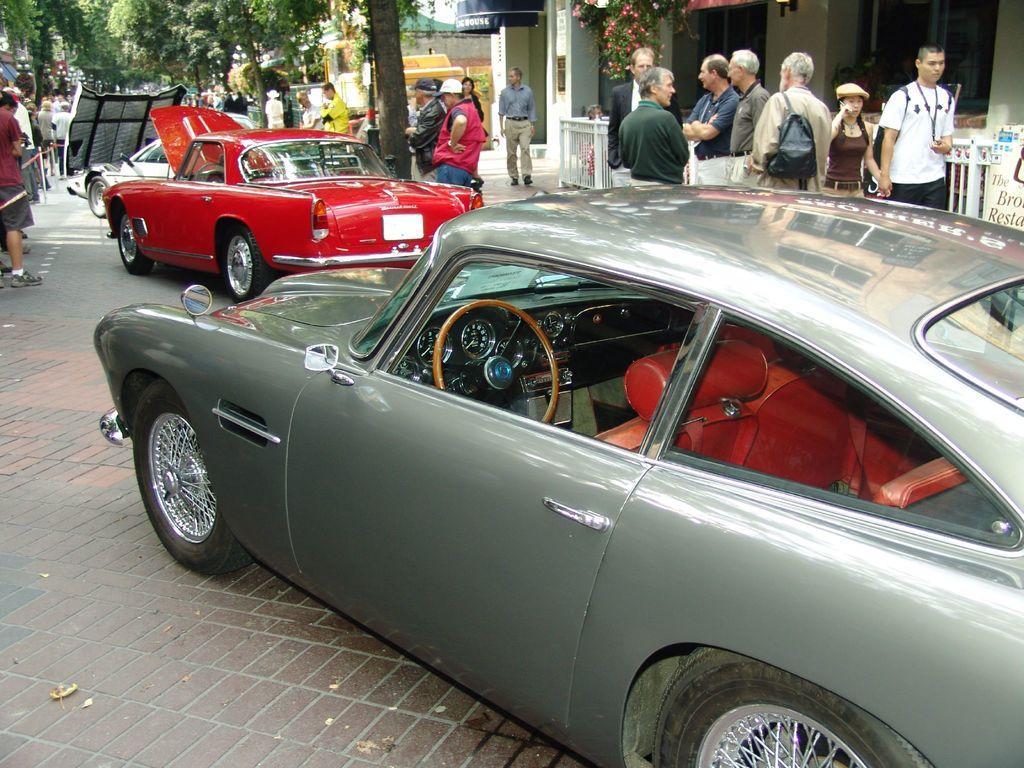Please provide a concise description of this image. In the foreground I can see fleets of cars and a crowd on the road. In the background I can see a building, trees, fence and the sky. This image is taken during a day. 